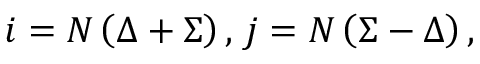<formula> <loc_0><loc_0><loc_500><loc_500>i = N \left ( \Delta + \Sigma \right ) , j = N \left ( \Sigma - \Delta \right ) ,</formula> 